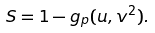Convert formula to latex. <formula><loc_0><loc_0><loc_500><loc_500>S = 1 - g _ { p } ( u , v ^ { 2 } ) .</formula> 